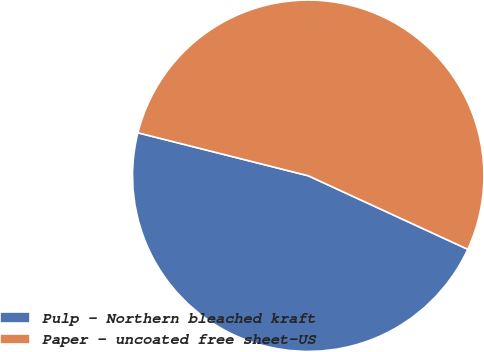Convert chart. <chart><loc_0><loc_0><loc_500><loc_500><pie_chart><fcel>Pulp - Northern bleached kraft<fcel>Paper - uncoated free sheet-US<nl><fcel>47.06%<fcel>52.94%<nl></chart> 